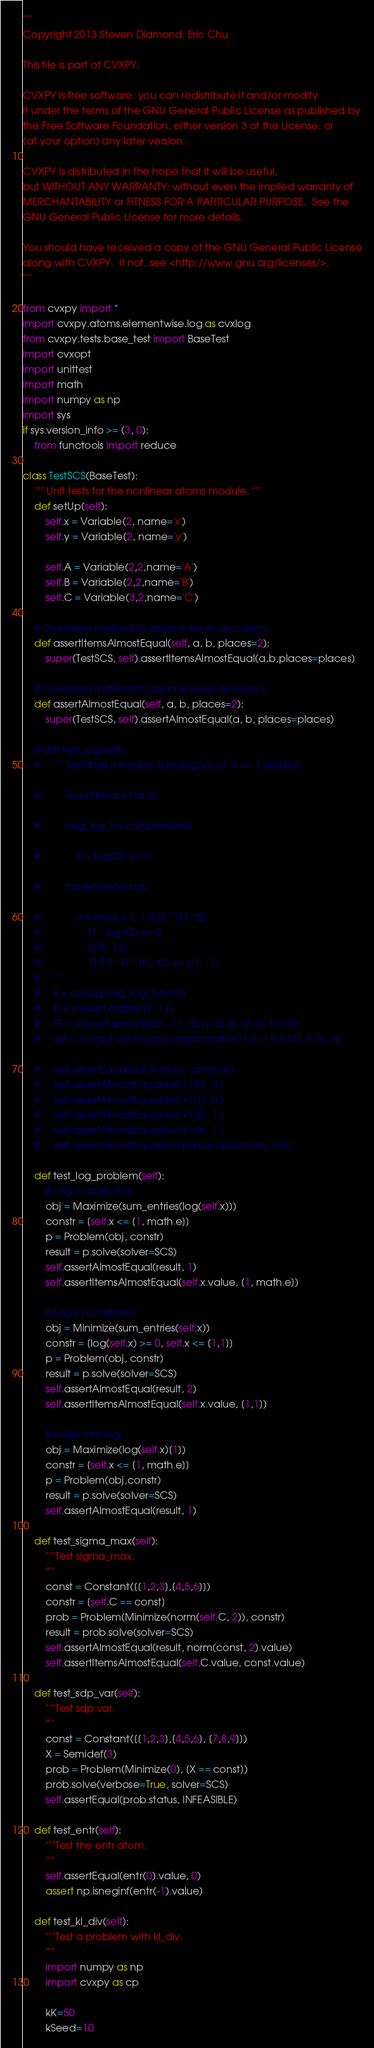Convert code to text. <code><loc_0><loc_0><loc_500><loc_500><_Python_>"""
Copyright 2013 Steven Diamond, Eric Chu

This file is part of CVXPY.

CVXPY is free software: you can redistribute it and/or modify
it under the terms of the GNU General Public License as published by
the Free Software Foundation, either version 3 of the License, or
(at your option) any later version.

CVXPY is distributed in the hope that it will be useful,
but WITHOUT ANY WARRANTY; without even the implied warranty of
MERCHANTABILITY or FITNESS FOR A PARTICULAR PURPOSE.  See the
GNU General Public License for more details.

You should have received a copy of the GNU General Public License
along with CVXPY.  If not, see <http://www.gnu.org/licenses/>.
"""

from cvxpy import *
import cvxpy.atoms.elementwise.log as cvxlog
from cvxpy.tests.base_test import BaseTest
import cvxopt
import unittest
import math
import numpy as np
import sys
if sys.version_info >= (3, 0):
    from functools import reduce

class TestSCS(BaseTest):
    """ Unit tests for the nonlinear atoms module. """
    def setUp(self):
        self.x = Variable(2, name='x')
        self.y = Variable(2, name='y')

        self.A = Variable(2,2,name='A')
        self.B = Variable(2,2,name='B')
        self.C = Variable(3,2,name='C')

    # Overriden method to assume lower accuracy.
    def assertItemsAlmostEqual(self, a, b, places=2):
        super(TestSCS, self).assertItemsAlmostEqual(a,b,places=places)

    # Overriden method to assume lower accuracy.
    def assertAlmostEqual(self, a, b, places=2):
        super(TestSCS, self).assertAlmostEqual(a, b, places=places)

    # def test_log(self):
    #     """ Test that minimize -sum(log(x)) s.t. x <= 1 yields 0.

    #         Rewritten by hand.

    #         neg_log_func implements

    #             t1 - log(t2) <= 0

    #         Implemented as

    #             minimize [-1,-1,0,0] * [t1; t2]
    #                 t1 - log(t2) <= 0
    #                 [0 0 -1 0;
    #                  0 0 0 -1] * [t1; t2] <= [-1; -1]
    #     """
    #     F = cvxlog.neg_log_func(2)
    #     h = cvxopt.matrix([1.,1.])
    #     G = cvxopt.spmatrix([1.,1.], [0,1], [2,3], (2,4), tc='d')
    #     sol = cvxopt.solver.cpl(cvxopt.matrix([-1.0,-1.0,0,0]), F, G, h)

    #     self.assertEqual(sol['status'], 'optimal')
    #     self.assertAlmostEqual(sol['x'][0], 0.)
    #     self.assertAlmostEqual(sol['x'][1], 0.)
    #     self.assertAlmostEqual(sol['x'][2], 1.)
    #     self.assertAlmostEqual(sol['x'][3], 1.)
    #     self.assertAlmostEqual(sol['primal objective'], 0.0)

    def test_log_problem(self):
        # Log in objective.
        obj = Maximize(sum_entries(log(self.x)))
        constr = [self.x <= [1, math.e]]
        p = Problem(obj, constr)
        result = p.solve(solver=SCS)
        self.assertAlmostEqual(result, 1)
        self.assertItemsAlmostEqual(self.x.value, [1, math.e])

        # Log in constraint.
        obj = Minimize(sum_entries(self.x))
        constr = [log(self.x) >= 0, self.x <= [1,1]]
        p = Problem(obj, constr)
        result = p.solve(solver=SCS)
        self.assertAlmostEqual(result, 2)
        self.assertItemsAlmostEqual(self.x.value, [1,1])

        # Index into log.
        obj = Maximize(log(self.x)[1])
        constr = [self.x <= [1, math.e]]
        p = Problem(obj,constr)
        result = p.solve(solver=SCS)
        self.assertAlmostEqual(result, 1)

    def test_sigma_max(self):
        """Test sigma_max.
        """
        const = Constant([[1,2,3],[4,5,6]])
        constr = [self.C == const]
        prob = Problem(Minimize(norm(self.C, 2)), constr)
        result = prob.solve(solver=SCS)
        self.assertAlmostEqual(result, norm(const, 2).value)
        self.assertItemsAlmostEqual(self.C.value, const.value)

    def test_sdp_var(self):
        """Test sdp var.
        """
        const = Constant([[1,2,3],[4,5,6], [7,8,9]])
        X = Semidef(3)
        prob = Problem(Minimize(0), [X == const])
        prob.solve(verbose=True, solver=SCS)
        self.assertEqual(prob.status, INFEASIBLE)

    def test_entr(self):
        """Test the entr atom.
        """
        self.assertEqual(entr(0).value, 0)
        assert np.isneginf(entr(-1).value)

    def test_kl_div(self):
        """Test a problem with kl_div.
        """
        import numpy as np
        import cvxpy as cp

        kK=50
        kSeed=10
</code> 